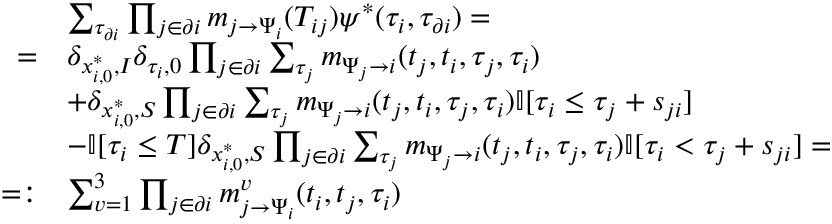Convert formula to latex. <formula><loc_0><loc_0><loc_500><loc_500>\begin{array} { r l } & { \sum _ { \tau _ { \partial i } } \prod _ { j \in \partial i } m _ { j \to \Psi _ { i } } ( T _ { i j } ) \psi ^ { * } ( \tau _ { i } , \tau _ { \partial i } ) = } \\ { = } & { \delta _ { x _ { i , 0 } ^ { * } , I } \delta _ { \tau _ { i } , 0 } \prod _ { j \in \partial i } \sum _ { \tau _ { j } } m _ { \Psi _ { j } \to i } ( t _ { j } , t _ { i } , \tau _ { j } , \tau _ { i } ) } \\ & { + \delta _ { x _ { i , 0 } ^ { * } , S } \prod _ { j \in \partial i } \sum _ { \tau _ { j } } m _ { \Psi _ { j } \to i } ( t _ { j } , t _ { i } , \tau _ { j } , \tau _ { i } ) \mathbb { I } [ \tau _ { i } \leq \tau _ { j } + s _ { j i } ] } \\ & { - \mathbb { I } [ \tau _ { i } \leq T ] \delta _ { x _ { i , 0 } ^ { * } , S } \prod _ { j \in \partial i } \sum _ { \tau _ { j } } m _ { \Psi _ { j } \to i } ( t _ { j } , t _ { i } , \tau _ { j } , \tau _ { i } ) \mathbb { I } [ \tau _ { i } < \tau _ { j } + s _ { j i } ] = } \\ { = \colon } & { \sum _ { v = 1 } ^ { 3 } \prod _ { j \in \partial i } m _ { j \to \Psi _ { i } } ^ { v } ( t _ { i } , t _ { j } , \tau _ { i } ) } \end{array}</formula> 